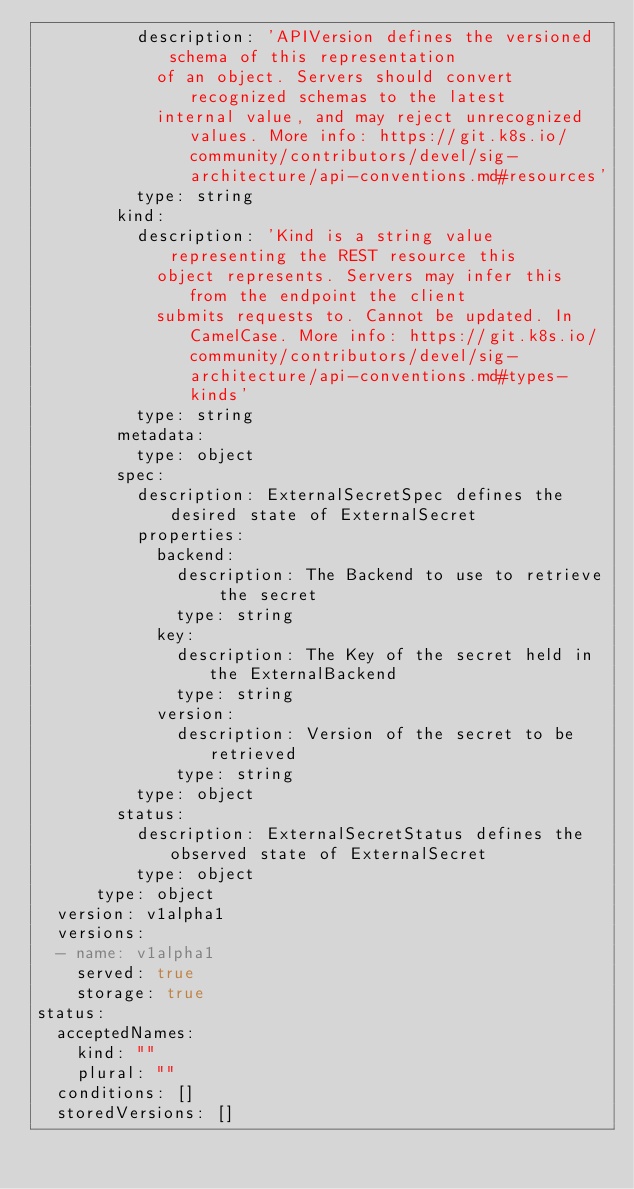<code> <loc_0><loc_0><loc_500><loc_500><_YAML_>          description: 'APIVersion defines the versioned schema of this representation
            of an object. Servers should convert recognized schemas to the latest
            internal value, and may reject unrecognized values. More info: https://git.k8s.io/community/contributors/devel/sig-architecture/api-conventions.md#resources'
          type: string
        kind:
          description: 'Kind is a string value representing the REST resource this
            object represents. Servers may infer this from the endpoint the client
            submits requests to. Cannot be updated. In CamelCase. More info: https://git.k8s.io/community/contributors/devel/sig-architecture/api-conventions.md#types-kinds'
          type: string
        metadata:
          type: object
        spec:
          description: ExternalSecretSpec defines the desired state of ExternalSecret
          properties:
            backend:
              description: The Backend to use to retrieve the secret
              type: string
            key:
              description: The Key of the secret held in the ExternalBackend
              type: string
            version:
              description: Version of the secret to be retrieved
              type: string
          type: object
        status:
          description: ExternalSecretStatus defines the observed state of ExternalSecret
          type: object
      type: object
  version: v1alpha1
  versions:
  - name: v1alpha1
    served: true
    storage: true
status:
  acceptedNames:
    kind: ""
    plural: ""
  conditions: []
  storedVersions: []
</code> 